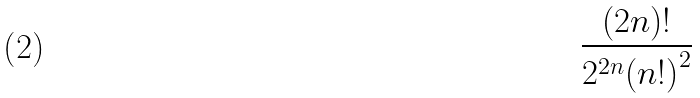Convert formula to latex. <formula><loc_0><loc_0><loc_500><loc_500>\frac { ( 2 n ) ! } { 2 ^ { 2 n } { ( n ! ) } ^ { 2 } }</formula> 